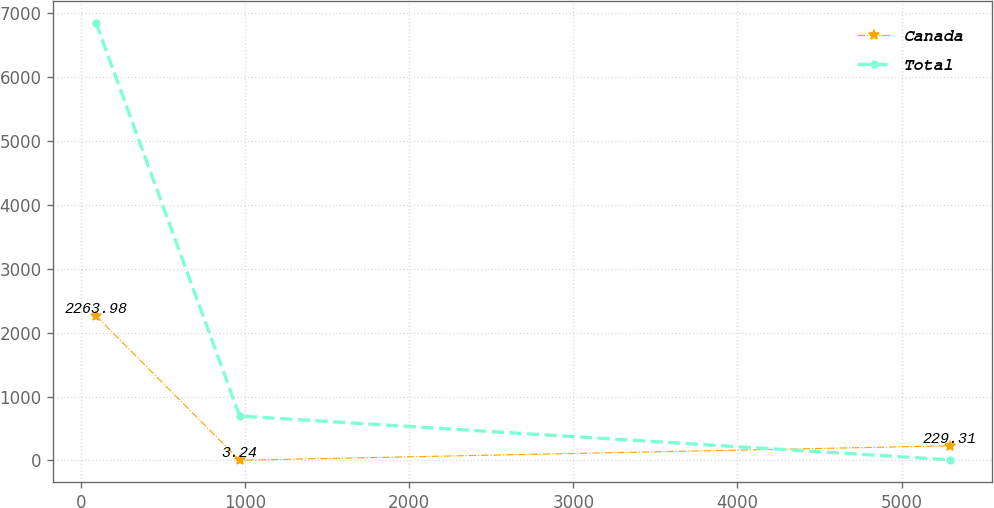Convert chart to OTSL. <chart><loc_0><loc_0><loc_500><loc_500><line_chart><ecel><fcel>Canada<fcel>Total<nl><fcel>91.98<fcel>2263.98<fcel>6852.56<nl><fcel>967.74<fcel>3.24<fcel>695.08<nl><fcel>5292.71<fcel>229.31<fcel>10.91<nl></chart> 